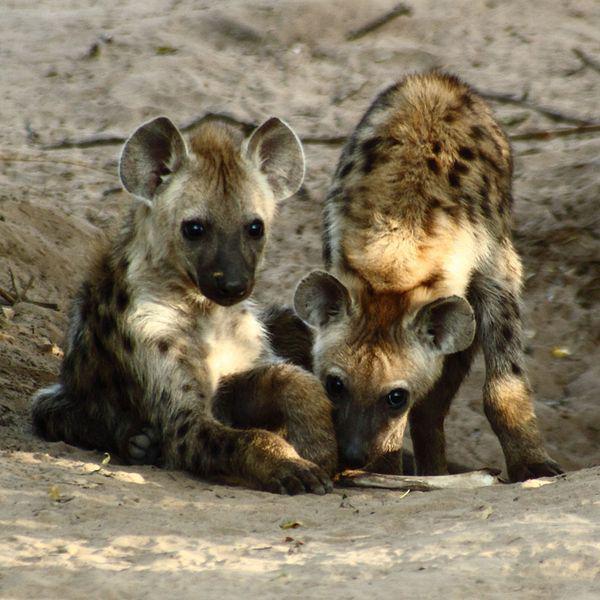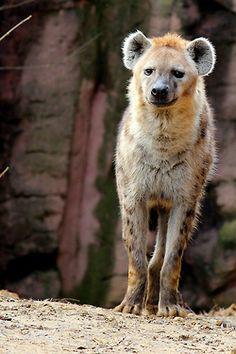The first image is the image on the left, the second image is the image on the right. Evaluate the accuracy of this statement regarding the images: "There are four hyenas.". Is it true? Answer yes or no. No. The first image is the image on the left, the second image is the image on the right. Assess this claim about the two images: "The lefthand image includes multiple hyenas, and at least one hyena stands with its nose bent to the ground.". Correct or not? Answer yes or no. Yes. 